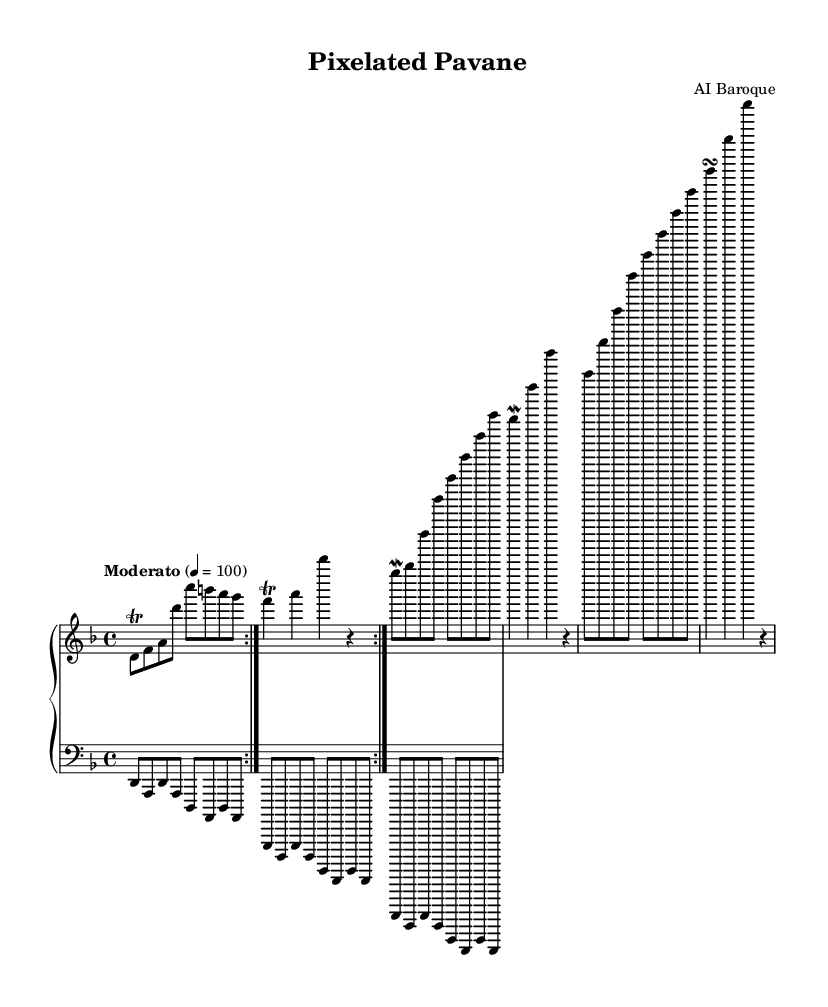What is the key signature of this music? The key signature shows two flats, indicating that the piece is in D minor.
Answer: D minor What is the time signature of this music? The time signature is indicated at the beginning of the score and shows a 4 over 4, which means there are four beats in a measure.
Answer: 4/4 What tempo marking is indicated for this piece? The tempo marking states "Moderato," which typically indicates a moderate speed, and it's specified to be at 100 beats per minute.
Answer: Moderato How many times is the first section of the right hand repeated? The notation indicates a "volta" with the repeat sign, suggesting that the first section of the right hand is repeated twice before moving on.
Answer: 2 What ornament is used in the right-hand part? The score shows the use of trills and mordents, which are types of ornaments typically found in Baroque music.
Answer: Trills and mordents What is the bottom clef used in the left-hand part of the score? The left-hand part uses the bass clef, which is common for the lower register of keyboard instruments.
Answer: Bass clef What type of piece does this composition represent? The overall title "Pixelated Pavane" suggests it represents a pavan, which is a slow dance form, and the retro game influence implies a modern twist on a traditional style.
Answer: Pavan 